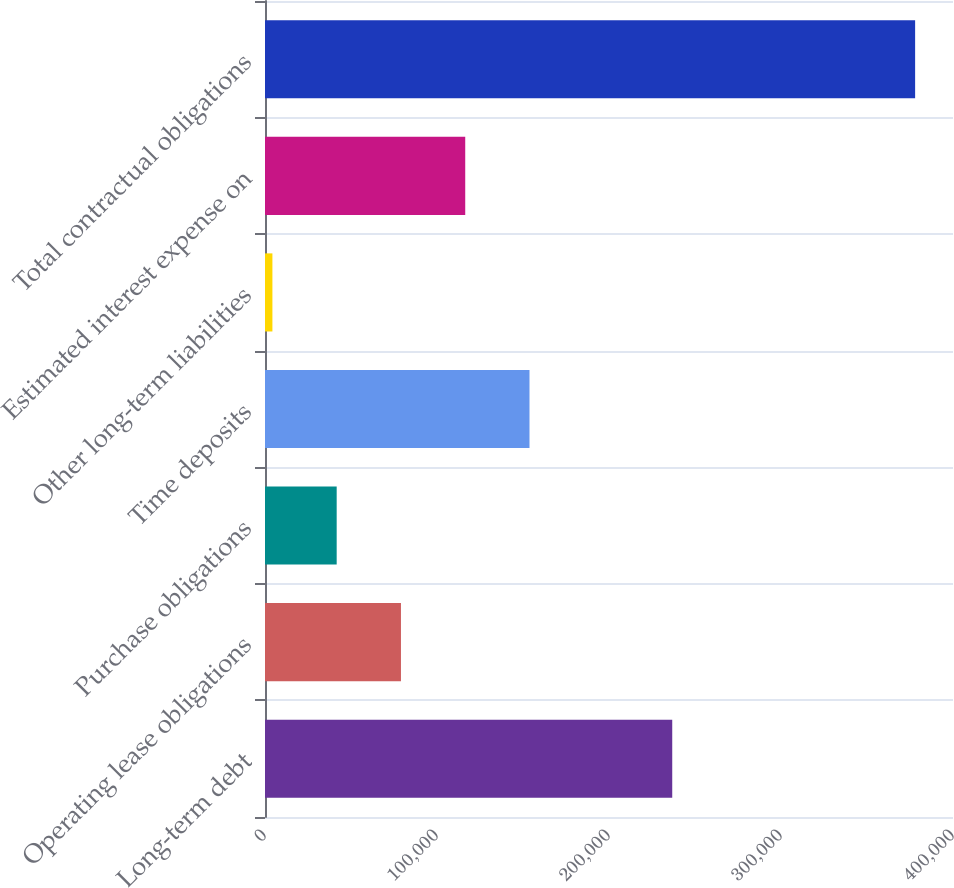<chart> <loc_0><loc_0><loc_500><loc_500><bar_chart><fcel>Long-term debt<fcel>Operating lease obligations<fcel>Purchase obligations<fcel>Time deposits<fcel>Other long-term liabilities<fcel>Estimated interest expense on<fcel>Total contractual obligations<nl><fcel>236764<fcel>79044.4<fcel>41677.7<fcel>153778<fcel>4311<fcel>116411<fcel>377978<nl></chart> 